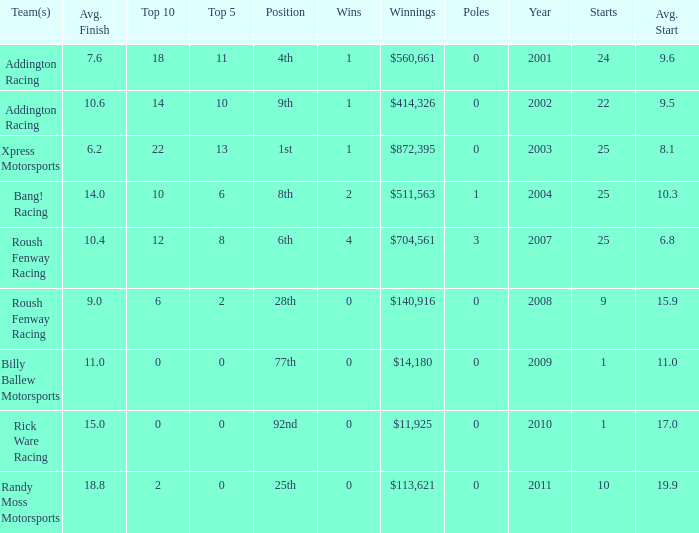What team or teams with 18 in the top 10? Addington Racing. 